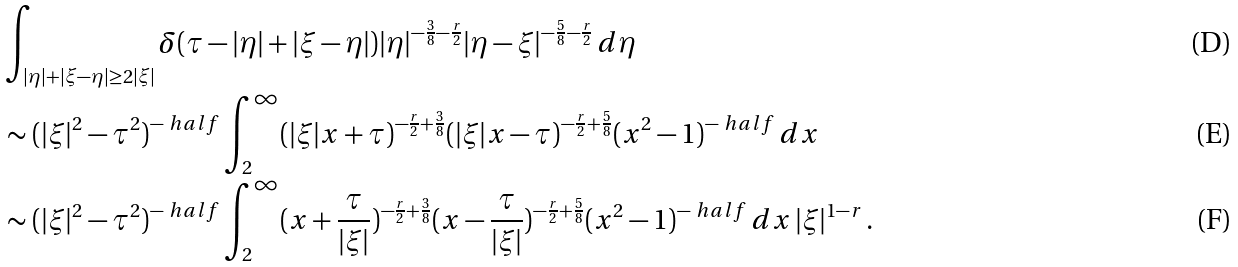Convert formula to latex. <formula><loc_0><loc_0><loc_500><loc_500>& \int _ { | \eta | + | \xi - \eta | \geq 2 | \xi | } \delta ( \tau - | \eta | + | \xi - \eta | ) | \eta | ^ { - \frac { 3 } { 8 } - \frac { r } { 2 } } | \eta - \xi | ^ { - \frac { 5 } { 8 } - \frac { r } { 2 } } \, d \eta \\ & \sim ( | \xi | ^ { 2 } - \tau ^ { 2 } ) ^ { - \ h a l f } \int _ { 2 } ^ { \infty } ( | \xi | x + \tau ) ^ { - \frac { r } { 2 } + \frac { 3 } { 8 } } ( | \xi | x - \tau ) ^ { - \frac { r } { 2 } + \frac { 5 } { 8 } } ( x ^ { 2 } - 1 ) ^ { - \ h a l f } \, d x \\ & \sim ( | \xi | ^ { 2 } - \tau ^ { 2 } ) ^ { - \ h a l f } \int _ { 2 } ^ { \infty } ( x + \frac { \tau } { | \xi | } ) ^ { - \frac { r } { 2 } + \frac { 3 } { 8 } } ( x - \frac { \tau } { | \xi | } ) ^ { - \frac { r } { 2 } + \frac { 5 } { 8 } } ( x ^ { 2 } - 1 ) ^ { - \ h a l f } \, d x \, | \xi | ^ { 1 - r } \, .</formula> 